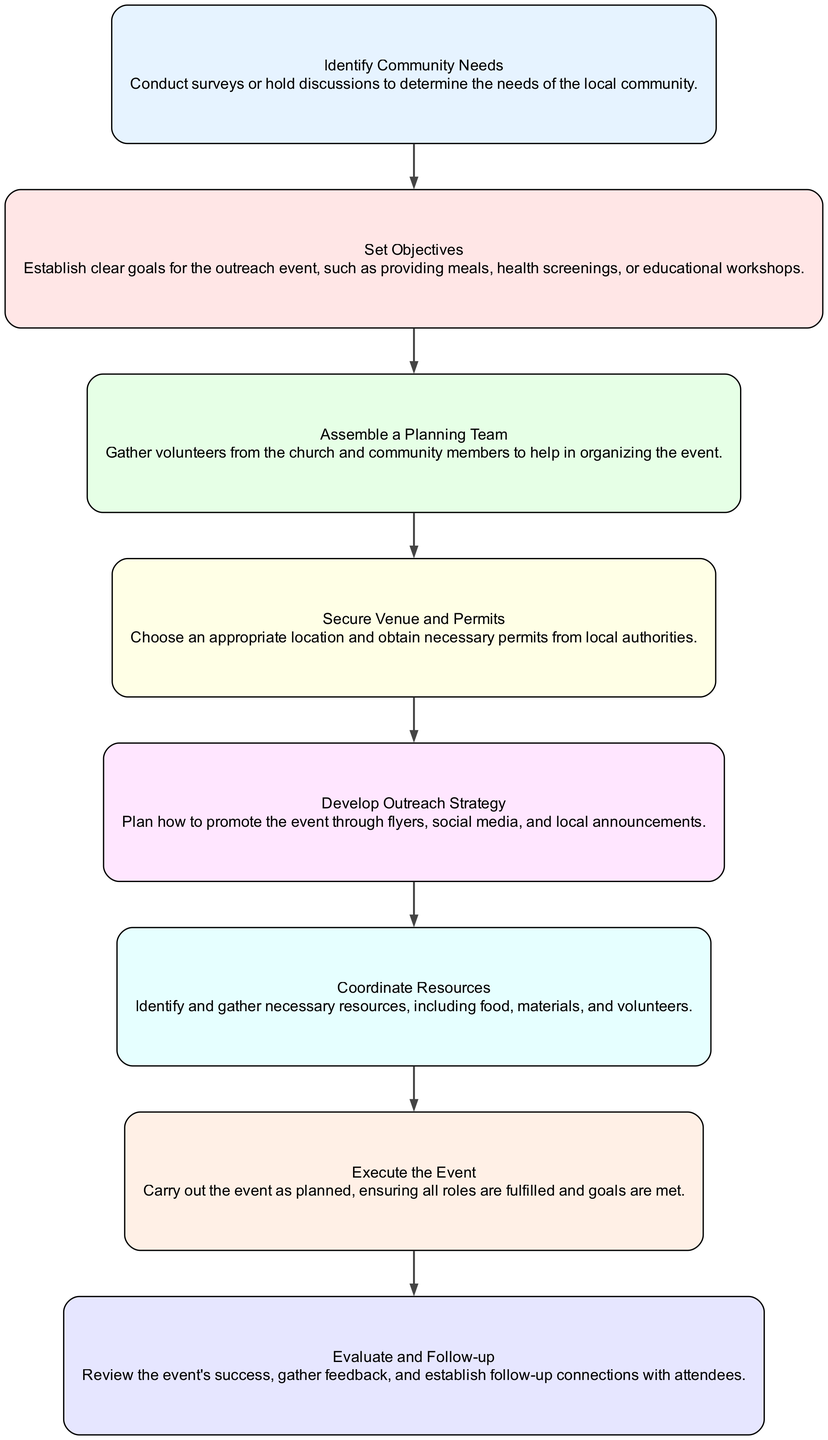What is the first step in organizing a community outreach event? The first step in the diagram is "Identify Community Needs." This is the first node, which indicates it is the starting point of the process.
Answer: Identify Community Needs How many total steps are there in the flow chart? The diagram contains eight steps listed sequentially from identification to evaluation and follow-up. Counting each of the steps reveals that there are eight in total.
Answer: 8 Which step follows "Assemble a Planning Team"? According to the diagram, the step following "Assemble a Planning Team" is "Secure Venue and Permits." This can be determined by looking at the edges connecting the nodes.
Answer: Secure Venue and Permits What is the main purpose of the "Evaluate and Follow-up" step? The purpose of the "Evaluate and Follow-up" step is to review the event's success and gather feedback. This can be directly derived from the node's description in the flow chart.
Answer: Review event's success and gather feedback What is the last step in the organizing process? The last step listed in the flow chart is "Evaluate and Follow-up." Since it is positioned at the end of the sequence, it signifies the conclusion of the organizing process.
Answer: Evaluate and Follow-up Describe the relationship between "Develop Outreach Strategy" and "Coordinate Resources." "Develop Outreach Strategy" is an earlier step that leads to "Coordinate Resources." The flow chart indicates this relationship with a directional edge connecting the two nodes, showing that one step naturally flows into the next.
Answer: Develop Outreach Strategy leads to Coordinate Resources What are examples of objectives to set in the outreach event? The objectives established in the step "Set Objectives" include providing meals, health screenings, or educational workshops. This information directly comes from the description of that node.
Answer: Providing meals, health screenings, or educational workshops How many nodes describe securing logistical aspects of the event? There are two nodes that describe securing logistical aspects: "Secure Venue and Permits" and "Coordinate Resources." These can be identified by their specific focus on venue and resource management within the process.
Answer: 2 